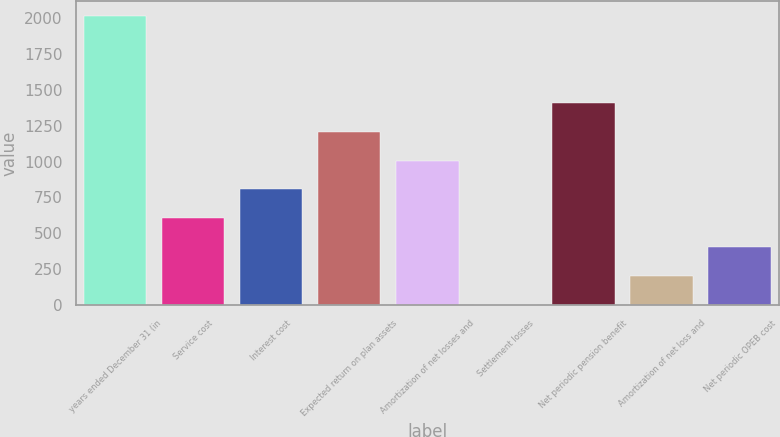<chart> <loc_0><loc_0><loc_500><loc_500><bar_chart><fcel>years ended December 31 (in<fcel>Service cost<fcel>Interest cost<fcel>Expected return on plan assets<fcel>Amortization of net losses and<fcel>Settlement losses<fcel>Net periodic pension benefit<fcel>Amortization of net loss and<fcel>Net periodic OPEB cost<nl><fcel>2013<fcel>604.6<fcel>805.8<fcel>1208.2<fcel>1007<fcel>1<fcel>1409.4<fcel>202.2<fcel>403.4<nl></chart> 